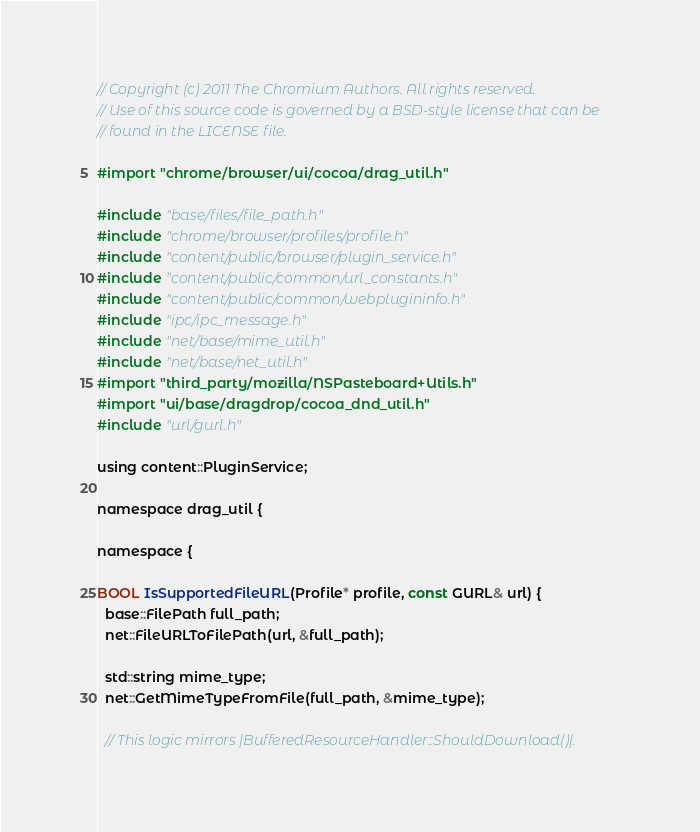Convert code to text. <code><loc_0><loc_0><loc_500><loc_500><_ObjectiveC_>// Copyright (c) 2011 The Chromium Authors. All rights reserved.
// Use of this source code is governed by a BSD-style license that can be
// found in the LICENSE file.

#import "chrome/browser/ui/cocoa/drag_util.h"

#include "base/files/file_path.h"
#include "chrome/browser/profiles/profile.h"
#include "content/public/browser/plugin_service.h"
#include "content/public/common/url_constants.h"
#include "content/public/common/webplugininfo.h"
#include "ipc/ipc_message.h"
#include "net/base/mime_util.h"
#include "net/base/net_util.h"
#import "third_party/mozilla/NSPasteboard+Utils.h"
#import "ui/base/dragdrop/cocoa_dnd_util.h"
#include "url/gurl.h"

using content::PluginService;

namespace drag_util {

namespace {

BOOL IsSupportedFileURL(Profile* profile, const GURL& url) {
  base::FilePath full_path;
  net::FileURLToFilePath(url, &full_path);

  std::string mime_type;
  net::GetMimeTypeFromFile(full_path, &mime_type);

  // This logic mirrors |BufferedResourceHandler::ShouldDownload()|.</code> 